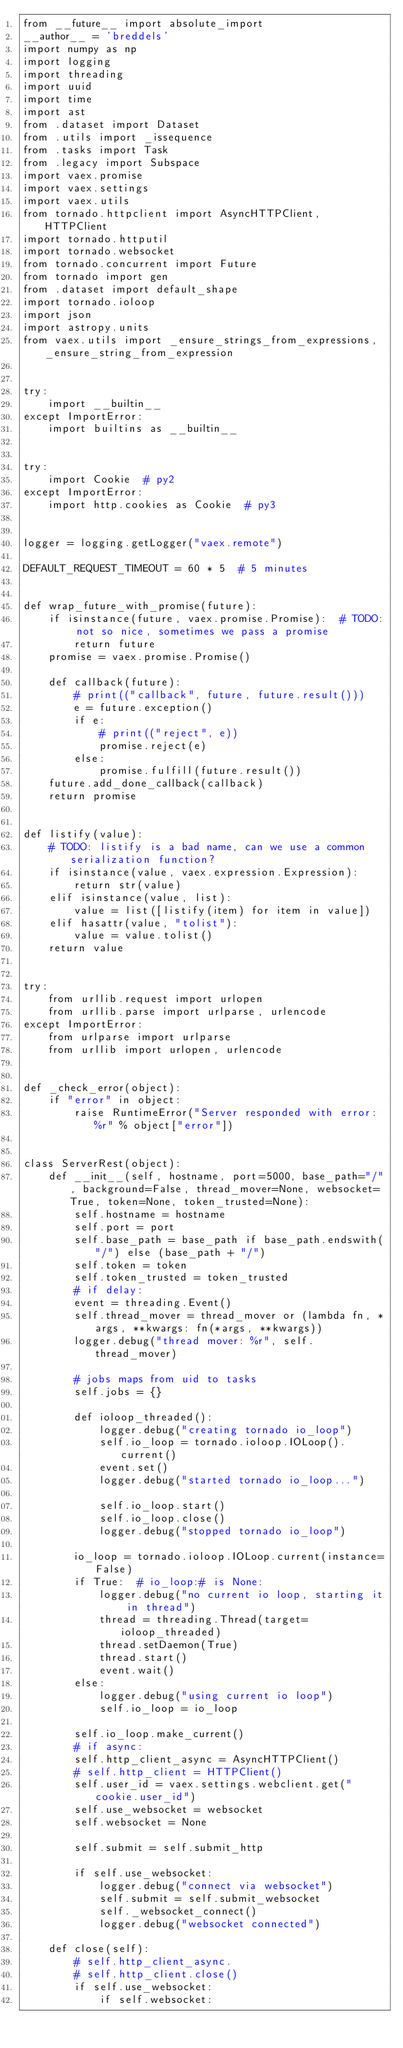<code> <loc_0><loc_0><loc_500><loc_500><_Python_>from __future__ import absolute_import
__author__ = 'breddels'
import numpy as np
import logging
import threading
import uuid
import time
import ast
from .dataset import Dataset
from .utils import _issequence
from .tasks import Task
from .legacy import Subspace
import vaex.promise
import vaex.settings
import vaex.utils
from tornado.httpclient import AsyncHTTPClient, HTTPClient
import tornado.httputil
import tornado.websocket
from tornado.concurrent import Future
from tornado import gen
from .dataset import default_shape
import tornado.ioloop
import json
import astropy.units
from vaex.utils import _ensure_strings_from_expressions, _ensure_string_from_expression


try:
    import __builtin__
except ImportError:
    import builtins as __builtin__


try:
    import Cookie  # py2
except ImportError:
    import http.cookies as Cookie  # py3


logger = logging.getLogger("vaex.remote")

DEFAULT_REQUEST_TIMEOUT = 60 * 5  # 5 minutes


def wrap_future_with_promise(future):
    if isinstance(future, vaex.promise.Promise):  # TODO: not so nice, sometimes we pass a promise
        return future
    promise = vaex.promise.Promise()

    def callback(future):
        # print(("callback", future, future.result()))
        e = future.exception()
        if e:
            # print(("reject", e))
            promise.reject(e)
        else:
            promise.fulfill(future.result())
    future.add_done_callback(callback)
    return promise


def listify(value):
    # TODO: listify is a bad name, can we use a common serialization function?
    if isinstance(value, vaex.expression.Expression):
        return str(value)
    elif isinstance(value, list):
        value = list([listify(item) for item in value])
    elif hasattr(value, "tolist"):
        value = value.tolist()
    return value


try:
    from urllib.request import urlopen
    from urllib.parse import urlparse, urlencode
except ImportError:
    from urlparse import urlparse
    from urllib import urlopen, urlencode


def _check_error(object):
    if "error" in object:
        raise RuntimeError("Server responded with error: %r" % object["error"])


class ServerRest(object):
    def __init__(self, hostname, port=5000, base_path="/", background=False, thread_mover=None, websocket=True, token=None, token_trusted=None):
        self.hostname = hostname
        self.port = port
        self.base_path = base_path if base_path.endswith("/") else (base_path + "/")
        self.token = token
        self.token_trusted = token_trusted
        # if delay:
        event = threading.Event()
        self.thread_mover = thread_mover or (lambda fn, *args, **kwargs: fn(*args, **kwargs))
        logger.debug("thread mover: %r", self.thread_mover)

        # jobs maps from uid to tasks
        self.jobs = {}

        def ioloop_threaded():
            logger.debug("creating tornado io_loop")
            self.io_loop = tornado.ioloop.IOLoop().current()
            event.set()
            logger.debug("started tornado io_loop...")

            self.io_loop.start()
            self.io_loop.close()
            logger.debug("stopped tornado io_loop")

        io_loop = tornado.ioloop.IOLoop.current(instance=False)
        if True:  # io_loop:# is None:
            logger.debug("no current io loop, starting it in thread")
            thread = threading.Thread(target=ioloop_threaded)
            thread.setDaemon(True)
            thread.start()
            event.wait()
        else:
            logger.debug("using current io loop")
            self.io_loop = io_loop

        self.io_loop.make_current()
        # if async:
        self.http_client_async = AsyncHTTPClient()
        # self.http_client = HTTPClient()
        self.user_id = vaex.settings.webclient.get("cookie.user_id")
        self.use_websocket = websocket
        self.websocket = None

        self.submit = self.submit_http

        if self.use_websocket:
            logger.debug("connect via websocket")
            self.submit = self.submit_websocket
            self._websocket_connect()
            logger.debug("websocket connected")

    def close(self):
        # self.http_client_async.
        # self.http_client.close()
        if self.use_websocket:
            if self.websocket:</code> 